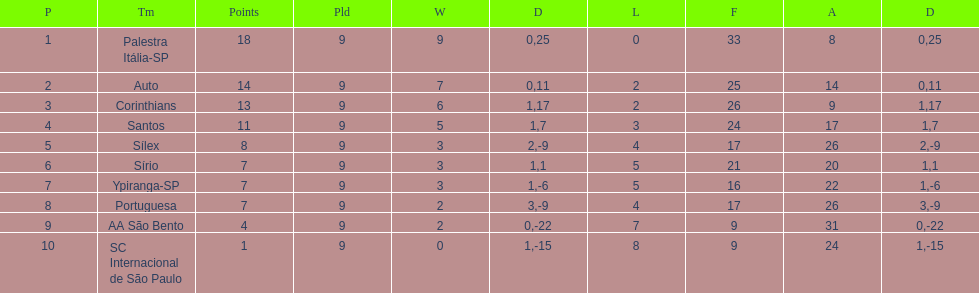In 1926 brazilian football,aside from the first place team, what other teams had winning records? Auto, Corinthians, Santos. 